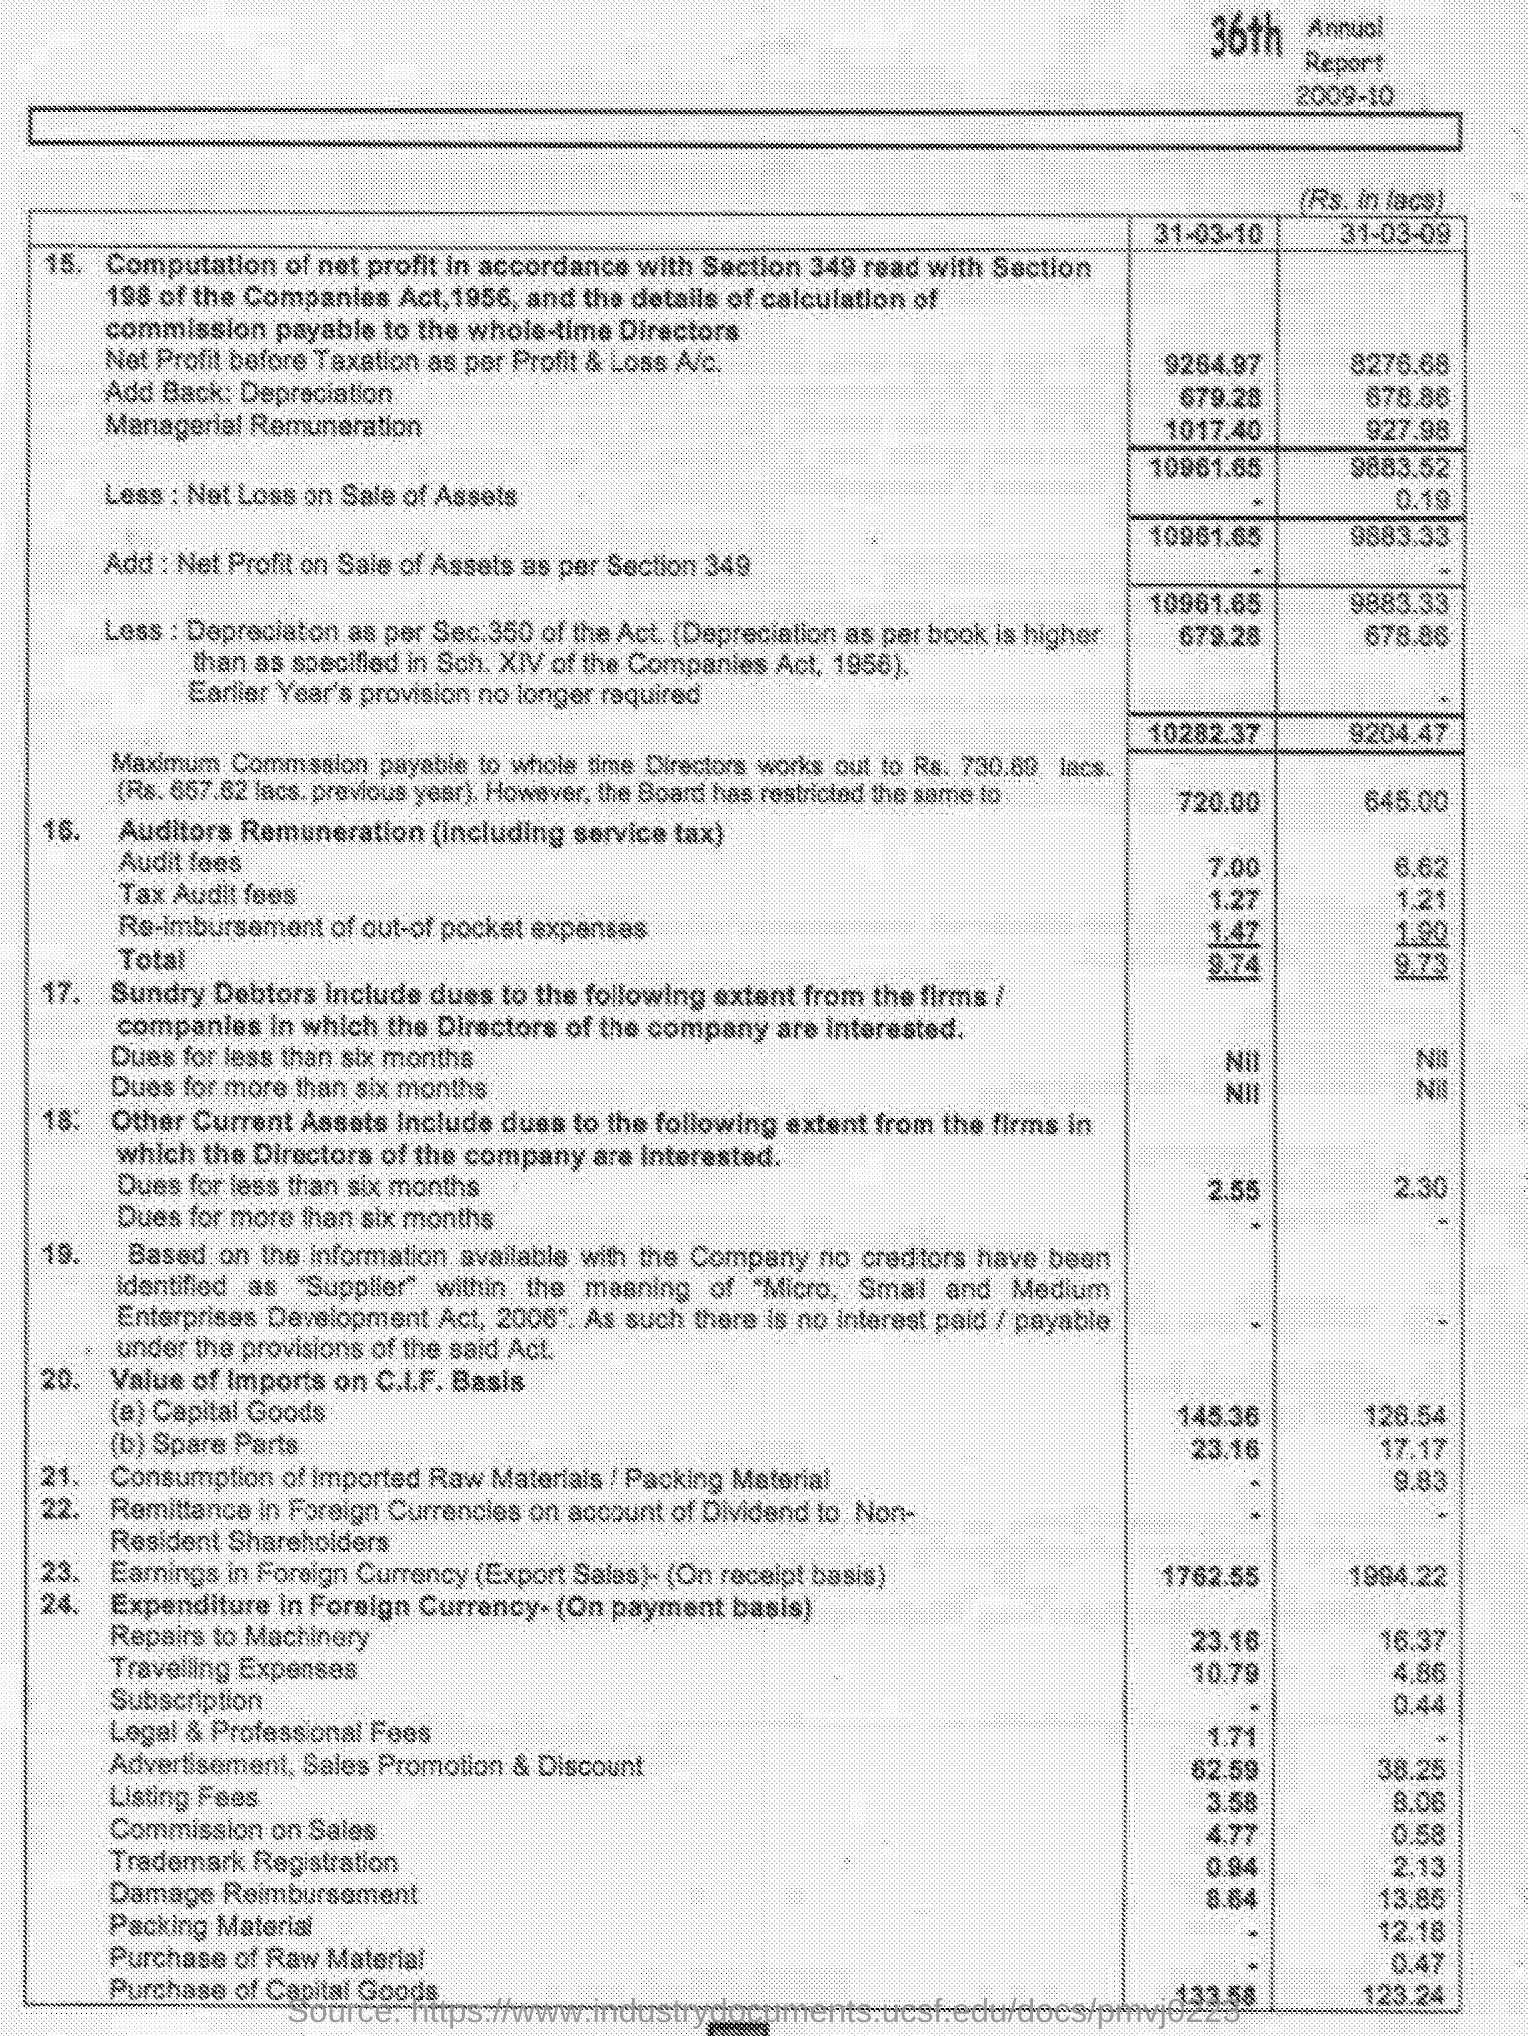Identify some key points in this picture. On 31 March 2010, the value of imports on the C.I.F basis for capital goods was 145.36. The value of imports on the C.I.F basis for spare parts on March 31st, 2009 was 17.17. The audit fees on March 31, 2010, were 7.00. On March 31, 2009, the consumption of imported raw materials was 9.83... On March 31, 2009, the tax audit fees were 1.21. 